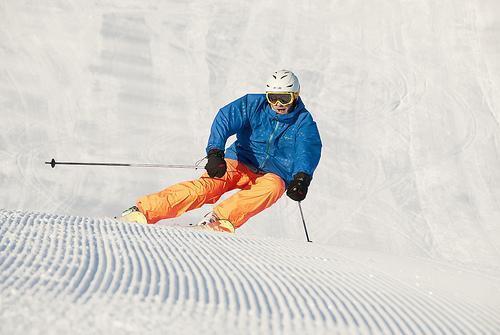How many men are there?
Give a very brief answer. 1. 